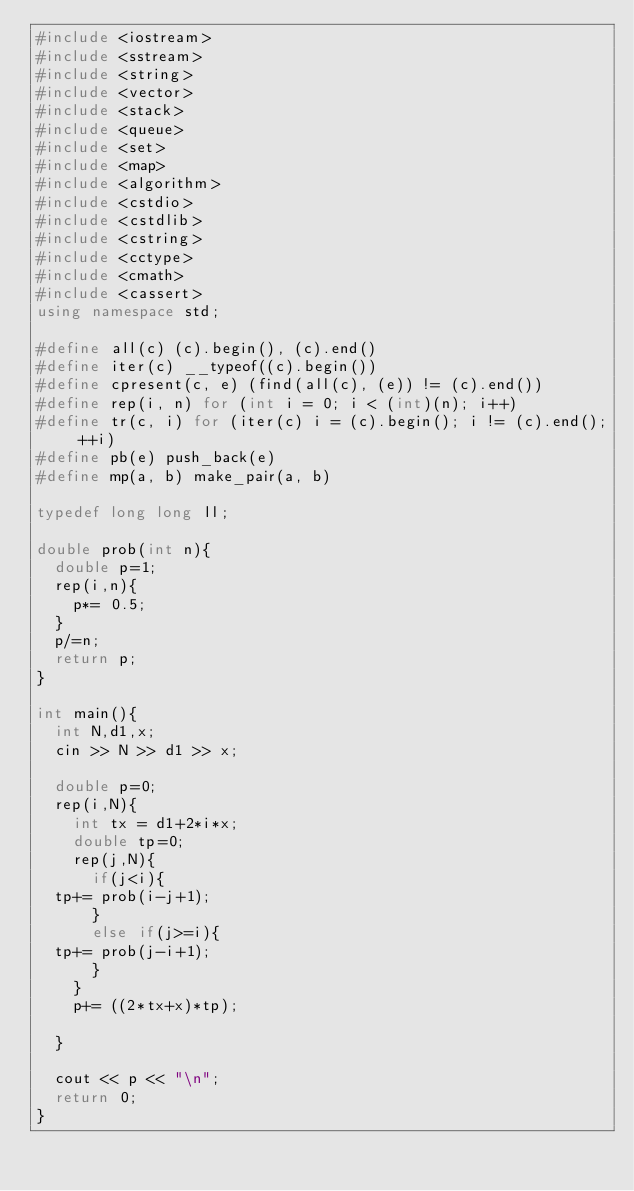Convert code to text. <code><loc_0><loc_0><loc_500><loc_500><_C++_>#include <iostream>
#include <sstream>
#include <string>
#include <vector>
#include <stack>
#include <queue>
#include <set>
#include <map>
#include <algorithm>
#include <cstdio>
#include <cstdlib>
#include <cstring>
#include <cctype>
#include <cmath>
#include <cassert>
using namespace std;

#define all(c) (c).begin(), (c).end()
#define iter(c) __typeof((c).begin())
#define cpresent(c, e) (find(all(c), (e)) != (c).end())
#define rep(i, n) for (int i = 0; i < (int)(n); i++)
#define tr(c, i) for (iter(c) i = (c).begin(); i != (c).end(); ++i)
#define pb(e) push_back(e)
#define mp(a, b) make_pair(a, b)

typedef long long ll;

double prob(int n){
  double p=1;
  rep(i,n){
    p*= 0.5;
  }
  p/=n;
  return p;
}

int main(){
  int N,d1,x;
  cin >> N >> d1 >> x;
  
  double p=0;
  rep(i,N){
    int tx = d1+2*i*x;
    double tp=0;
    rep(j,N){
      if(j<i){  
	tp+= prob(i-j+1);
      }
      else if(j>=i){
	tp+= prob(j-i+1);
      }
    }
    p+= ((2*tx+x)*tp);
   
  }

  cout << p << "\n";
  return 0;
}
</code> 